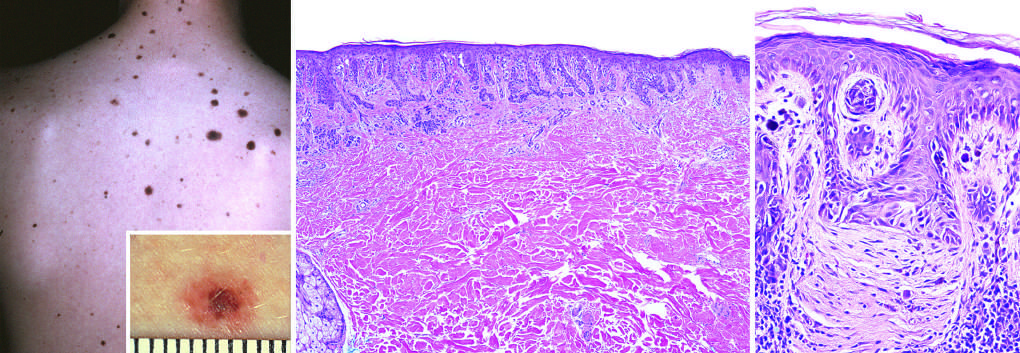does this lesion correspond to the less pigmented flat peripheral rim?
Answer the question using a single word or phrase. No 